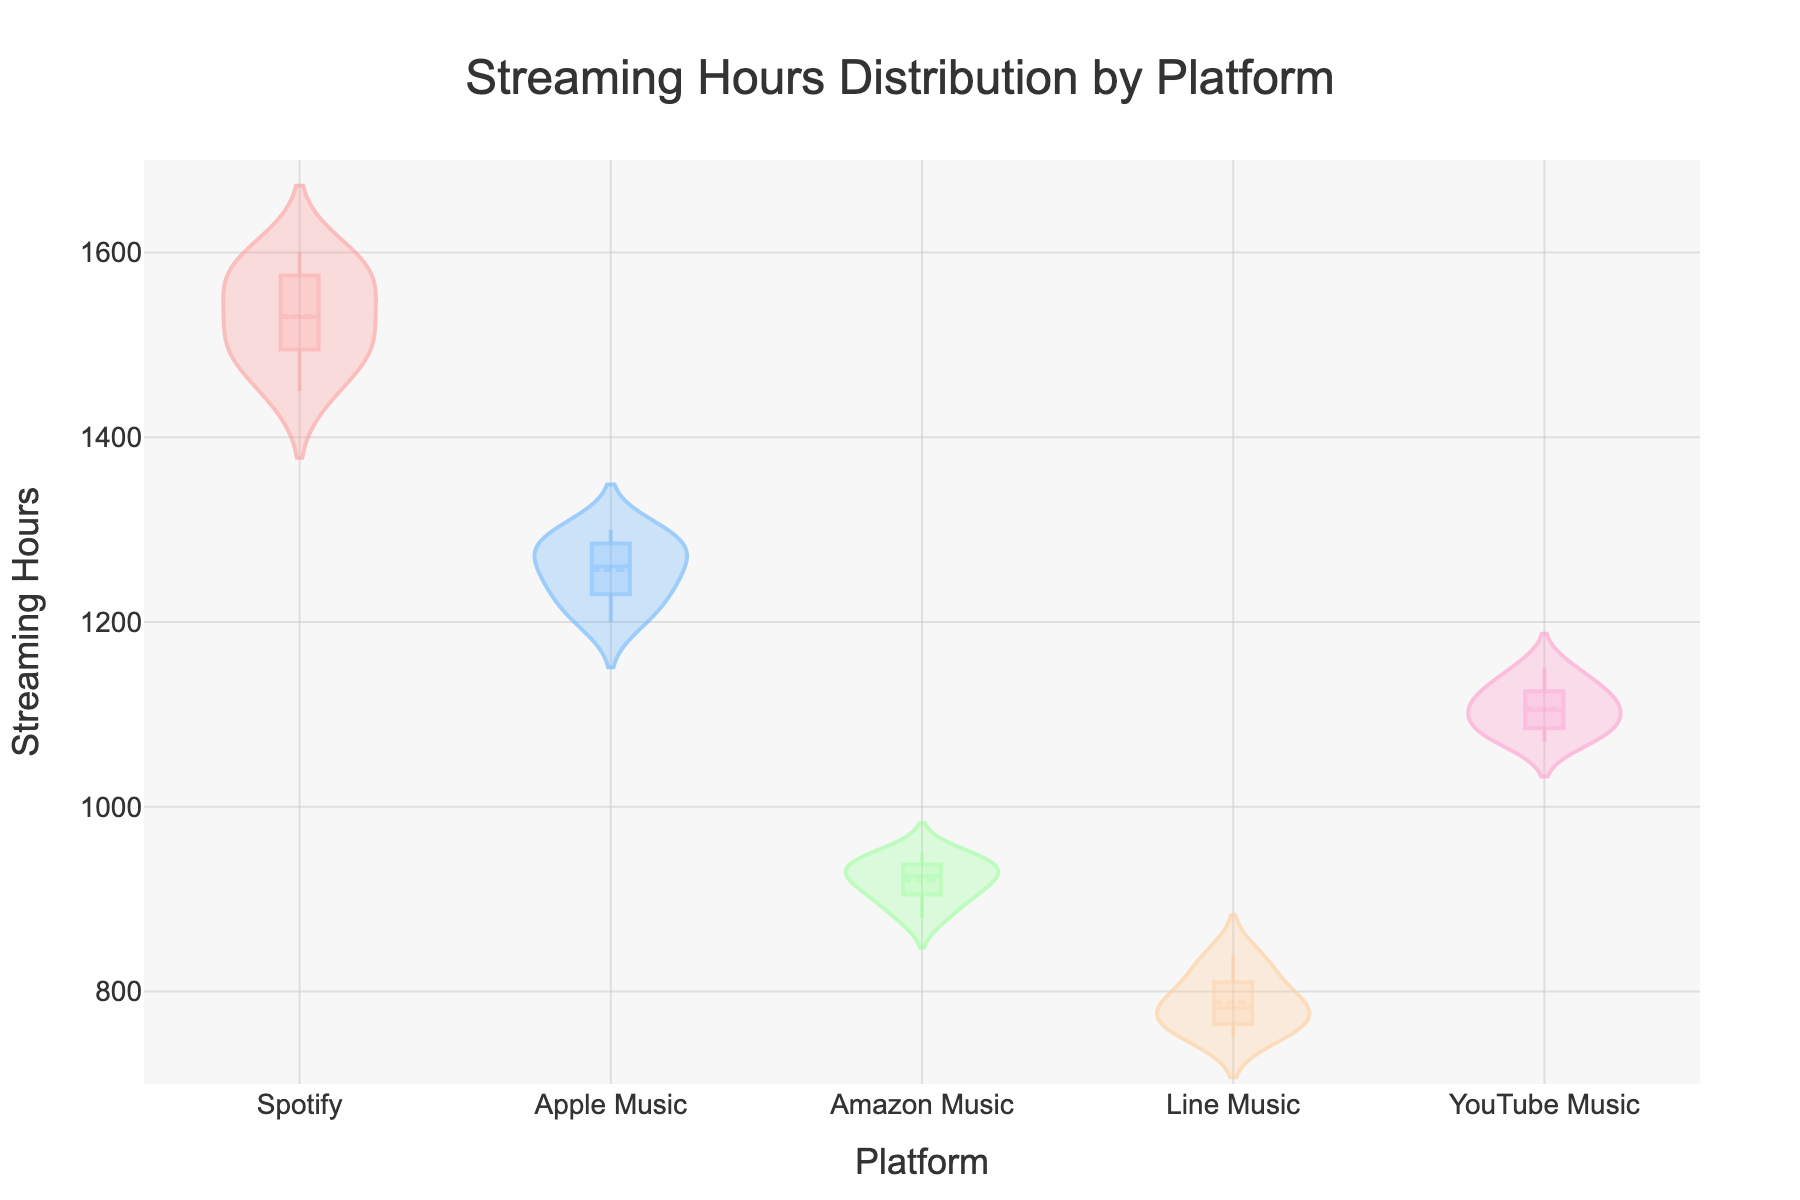What is the title of the figure? The title of the figure is displayed at the top and reads "Streaming Hours Distribution by Platform".
Answer: Streaming Hours Distribution by Platform Which platform has the highest median streaming hours? The figure shows violin plots for each platform with a white dot representing the median. The platform with the highest median streaming hours is Spotify.
Answer: Spotify What range of streaming hours does Amazon Music cover? The Amazon Music violin plot extends from approximately 880 to 950 streaming hours.
Answer: 880 to 950 Which platform has the most variation in streaming hours? By looking at the width and spread of the violin plots, the platform with the widest plot is Spotify, indicating the most variation in streaming hours.
Answer: Spotify Are the mean lines visible in the plot? The plot includes a meanline in each violin plot, depicted as a straight line through each plot.
Answer: Yes How does the median streaming hours of Line Music compare to that of Apple Music? The median of Line Music is around 780, while the median of Apple Music is around 1250, showing that Apple Music's median is higher.
Answer: Apple Music's median is higher What's the typical range of streaming hours for YouTube Music? Observing the spread of the YouTube Music violin plot, the range is approximately between 1070 and 1150 streaming hours.
Answer: 1070 to 1150 Which platform has the smallest interquartile range (IQR)? Judging by the density and containment of the plots, Amazon Music has the smallest interquartile range, roughly between 910 and 940 streaming hours.
Answer: Amazon Music What is the color of the box plot for Line Music? The box plot for Line Music is colored in a light peach shade.
Answer: Light peach 